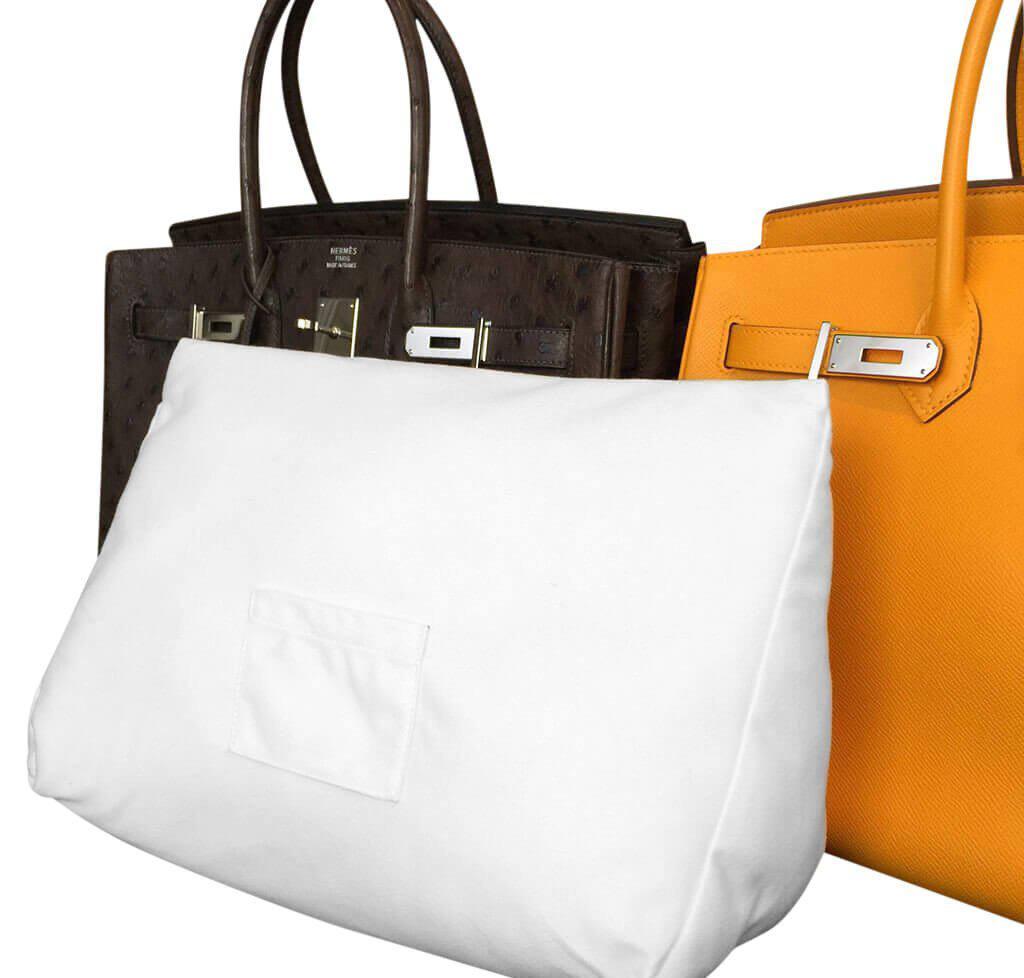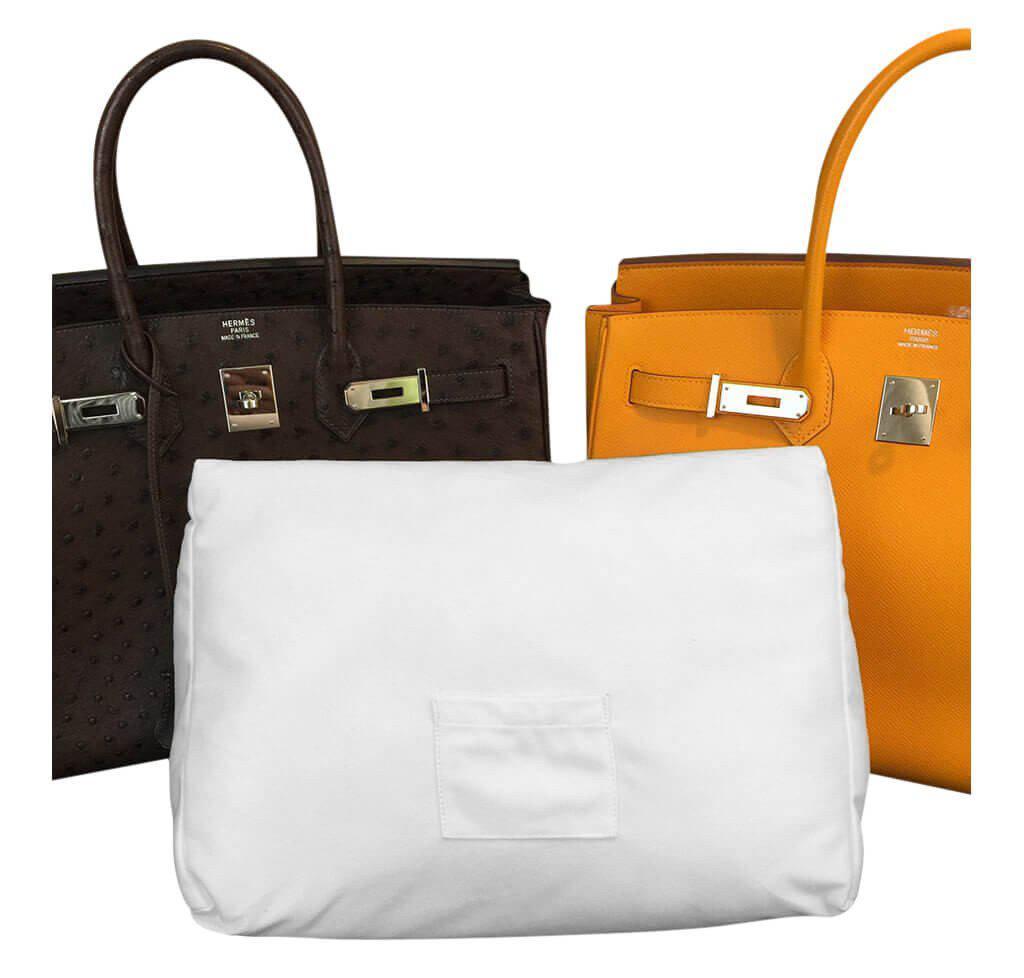The first image is the image on the left, the second image is the image on the right. Considering the images on both sides, is "Each image shows two different colored handbags with double handles and metal trim sitting behind a white stuffed pillow form." valid? Answer yes or no. Yes. The first image is the image on the left, the second image is the image on the right. Evaluate the accuracy of this statement regarding the images: "At least one image shows a dark brown bag and a golden-yellow bag behind a white pillow.". Is it true? Answer yes or no. Yes. 